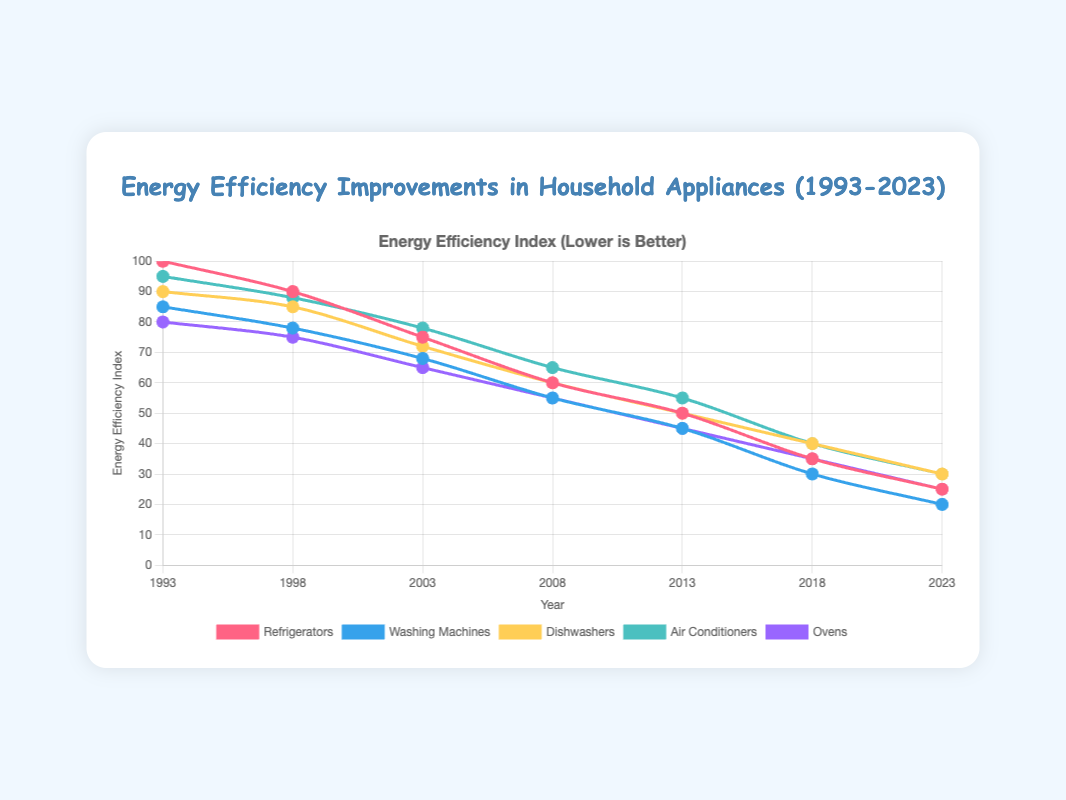What's the trend of energy efficiency in refrigerators over 30 years? The energy efficiency index for refrigerators starts at 100 in 1993 and decreases to 25 in 2023. This indicates a continuous improvement in energy efficiency.
Answer: Continuous improvement In which year did the washing machines surpass the 50% mark in energy efficiency improvement? By examining the washing machines' data, they crossed below an index value of 50 in the year 2013 with a value of 45.
Answer: 2013 Between 1993 and 2023, which appliance showed the least improvement in energy efficiency? By comparing the reduction in energy efficiency indices, dishwashers decreased from 90 to 30, a 60-point reduction, which is less compared to other appliances whose reductions ranged from 65 to 75 points.
Answer: Dishwashers What is the difference in energy efficiency between air conditioners and ovens in the year 2008? In 2008, the energy efficiency index for air conditioners is 65, and for ovens, it's 55. The difference is 65 - 55 = 10.
Answer: 10 Which appliance had the lowest energy efficiency index in 2023? In 2023, all indices are refrenced, and washing machines have the lowest with an index value of 20.
Answer: Washing machines How much did the energy efficiency for dishwashers improve from 1993 to 2003? The energy efficiency index for dishwashers in 1993 is 90 and in 2003 is 72. The improvement is 90 - 72 = 18.
Answer: 18 What is the average energy efficiency index for ovens across all recorded years? Adding the indices for ovens across the years gives (80 + 75 + 65 + 55 + 45 + 35 + 25) = 380, and there are 7 years. The average is 380 / 7 = approximately 54.29.
Answer: Approximately 54.29 Which year shows the greatest overall reduction in energy efficiency across all appliances from the previous year? To find the greatest reduction, we calculate the difference in indices for each year transition and sum across all appliances. The 1998-2003 interval shows significant drops in multiple appliances, with an evident overall sharp decline.
Answer: 2003 How did the energy efficiency of air conditioners and refrigerators compare in 2023? In 2023, air conditioners have an efficiency index of 30, and refrigerators have an efficiency index of 25, indicating refrigerators are more energy-efficient.
Answer: Refrigerators are more efficient What is the rate of improvement per year for washing machines from 1993 to 2023? Over 30 years (2023 - 1993), the energy efficiency index for washing machines decreases from 85 to 20. The rate is (85 - 20) / 30 = approximately 2.17 per year.
Answer: Approximately 2.17 per year 